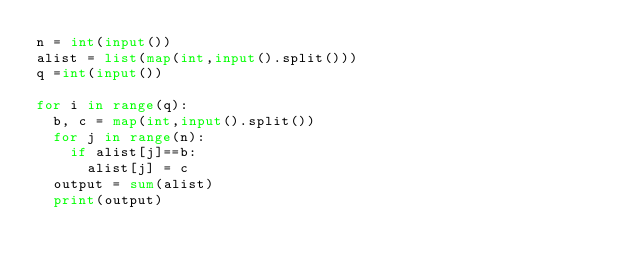<code> <loc_0><loc_0><loc_500><loc_500><_Python_>n = int(input())
alist = list(map(int,input().split()))
q =int(input())

for i in range(q):
  b, c = map(int,input().split())
  for j in range(n):
    if alist[j]==b:
      alist[j] = c
  output = sum(alist)
  print(output)</code> 